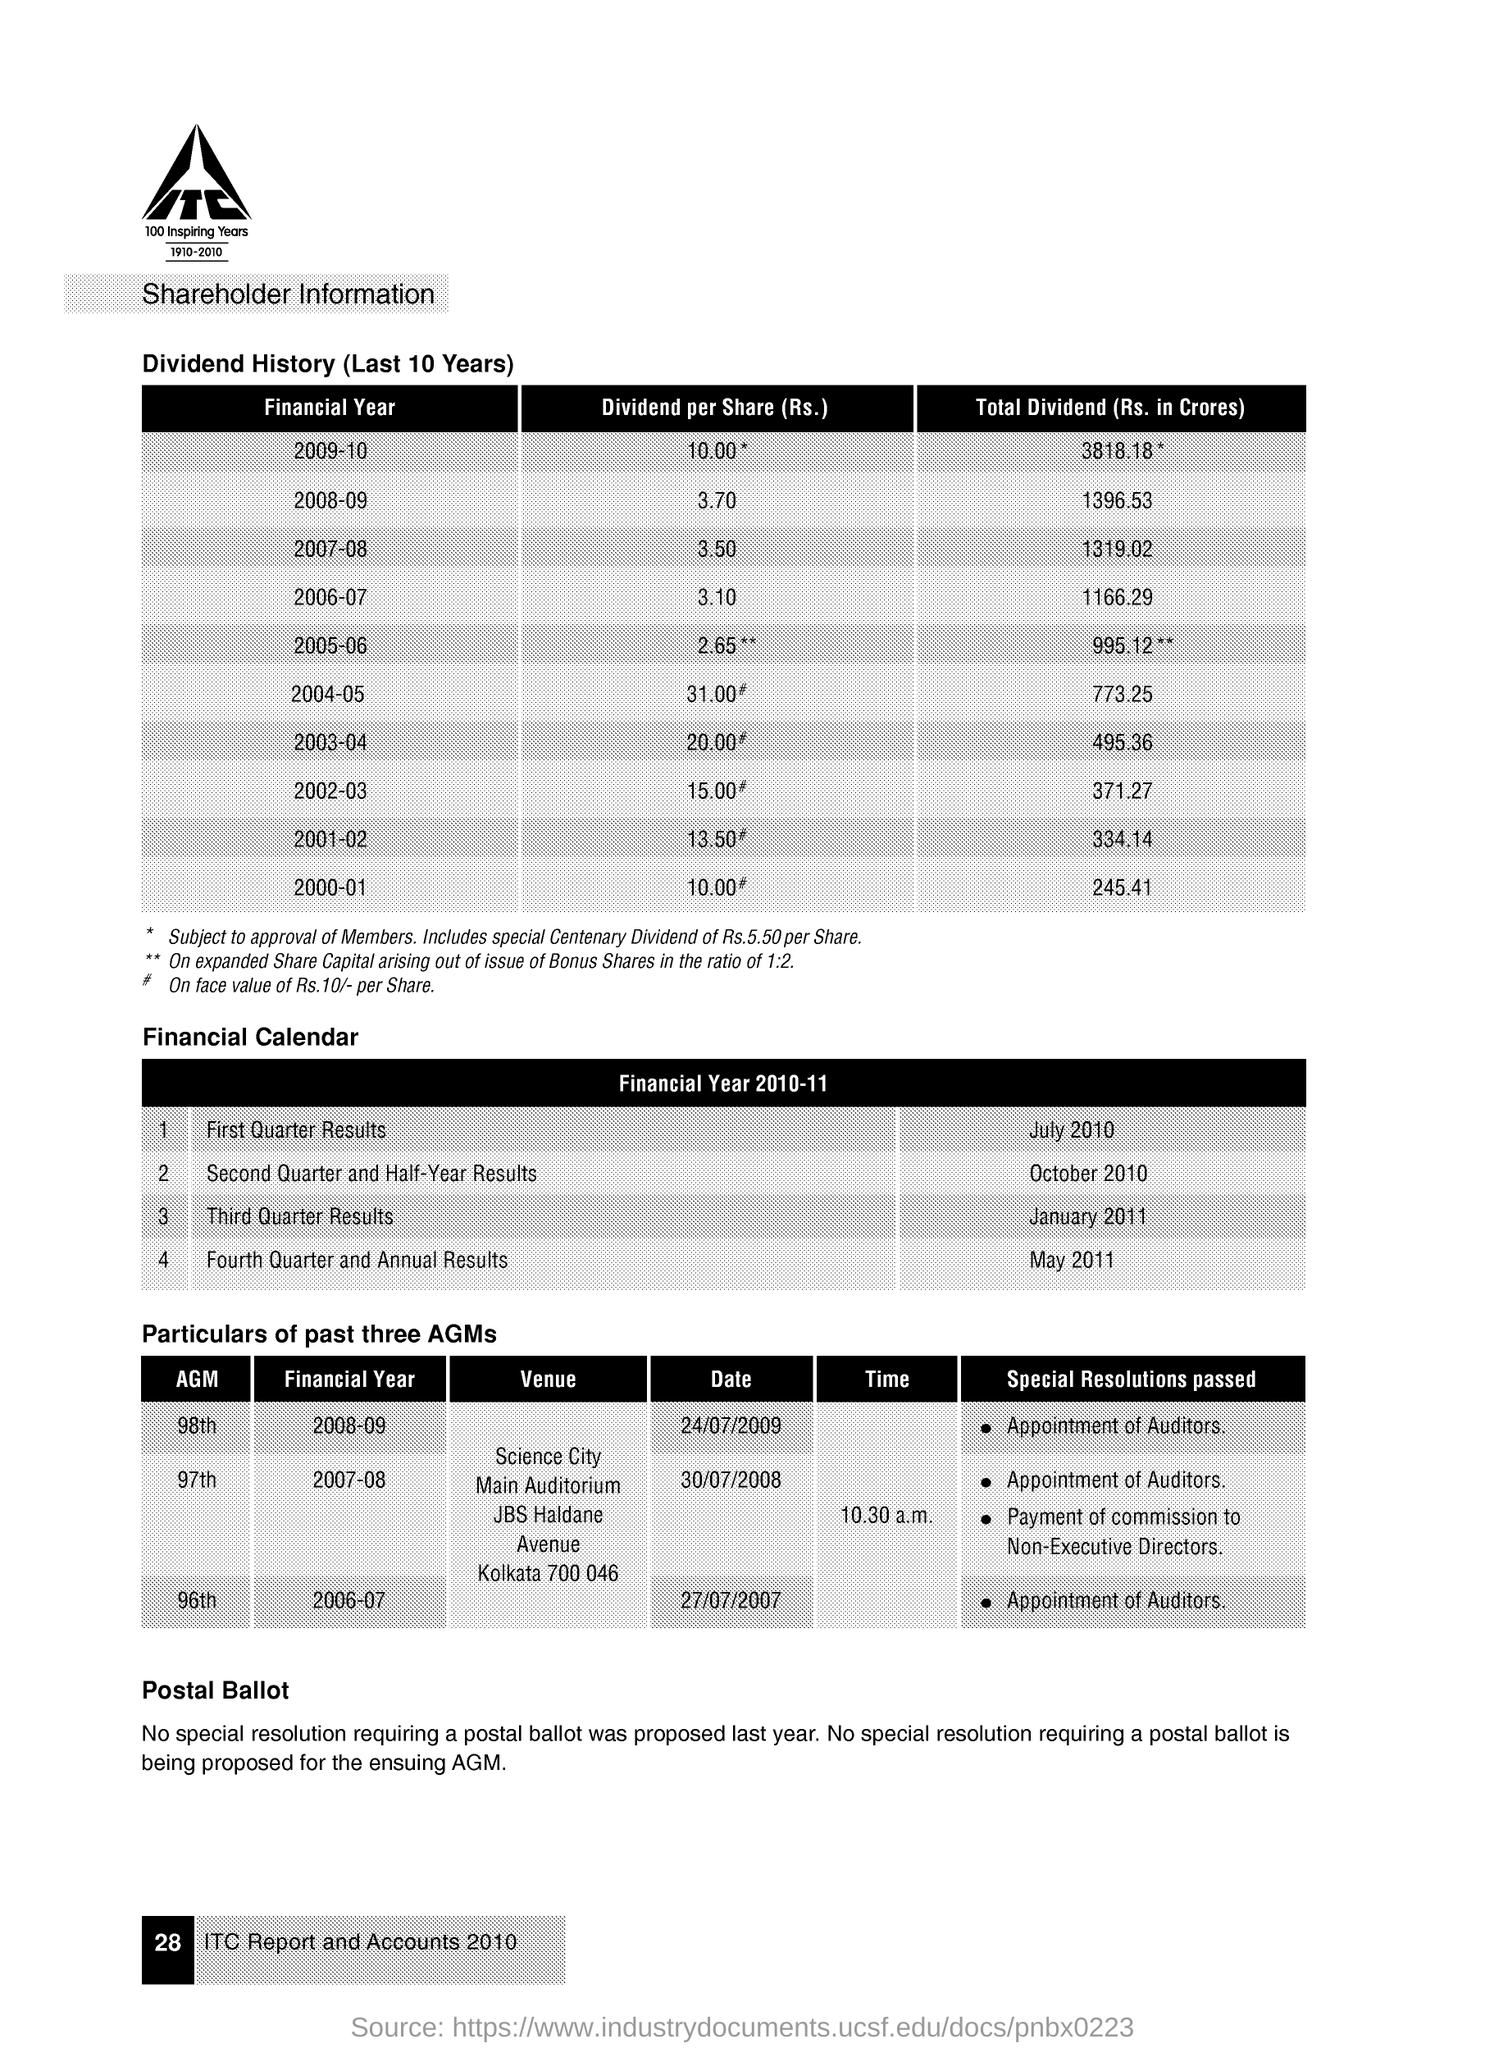What is the Dividend per Share(Rs.) for the Financial Year 2008-09? For the Financial Year 2008-09, the Dividend per Share was Rs. 3.70 as presented in the Shareholder Information document. 